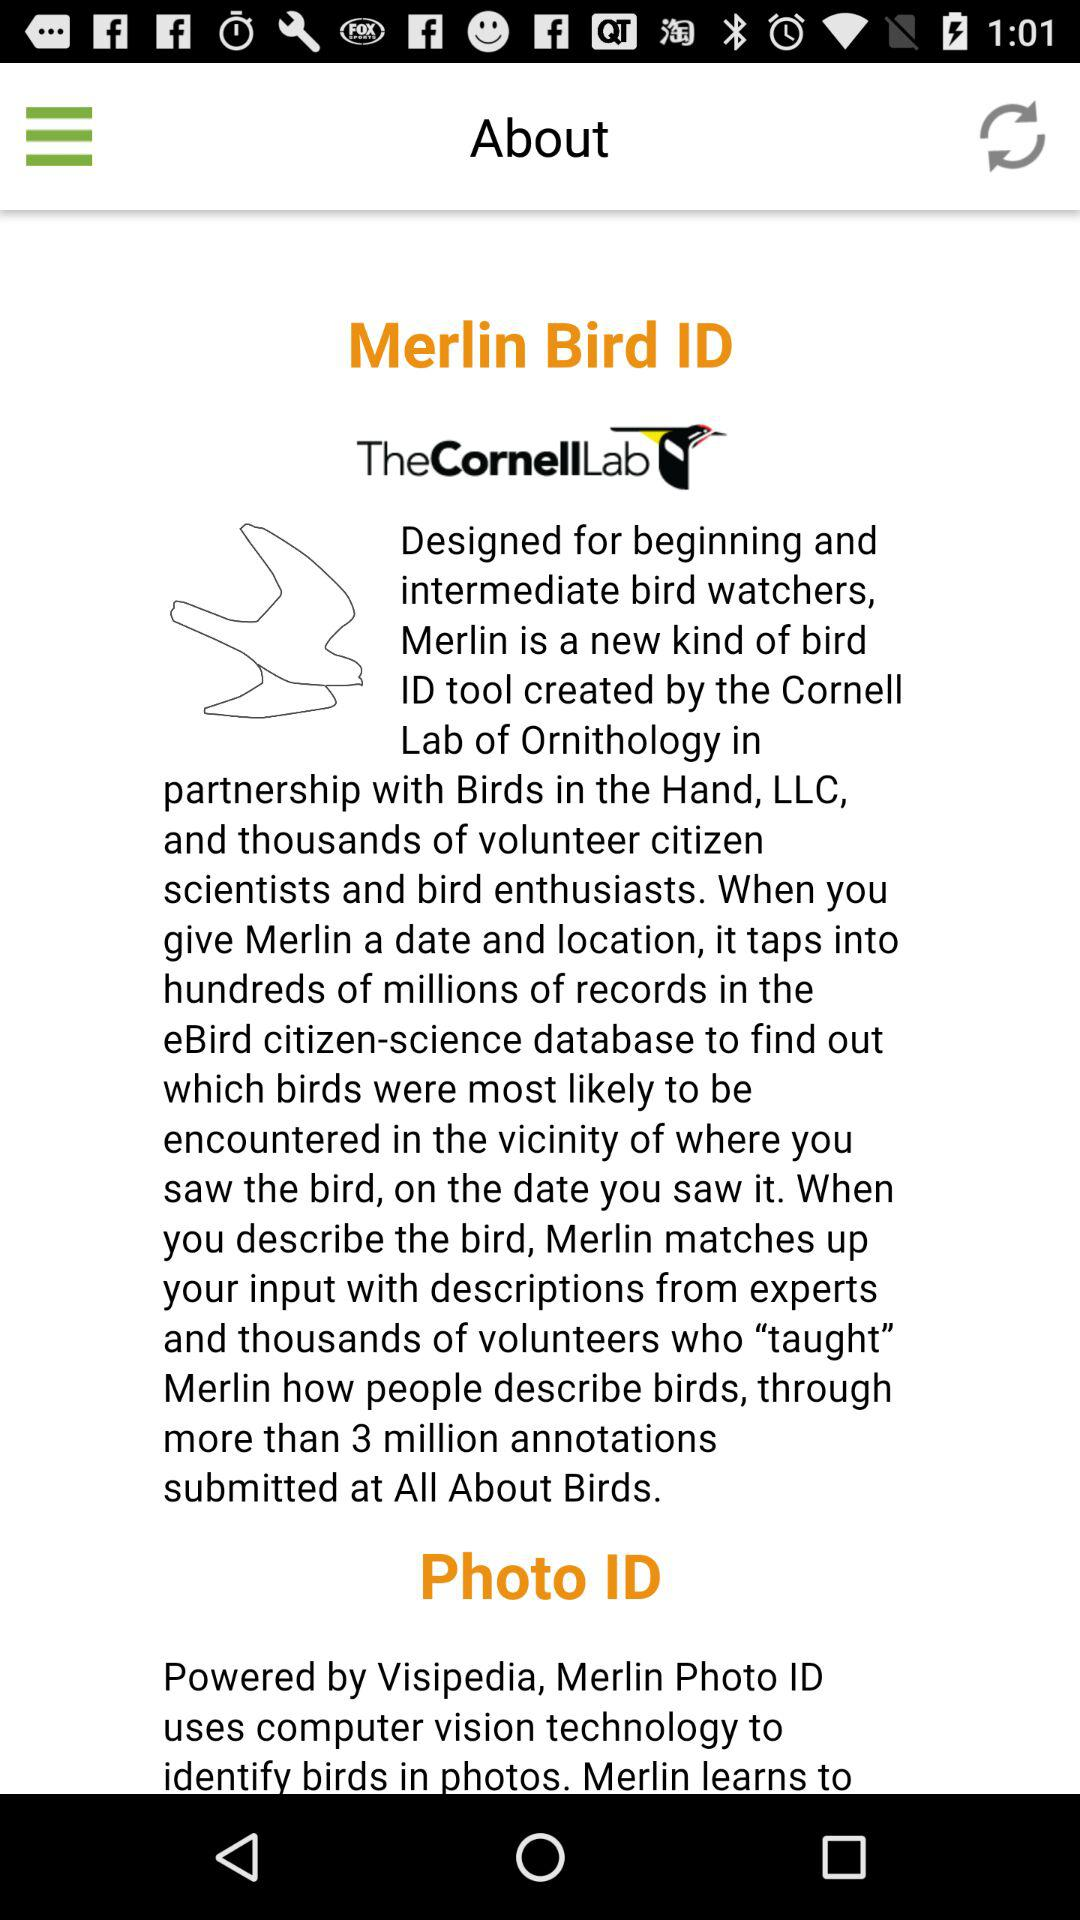What is Merlin Bird Id?
When the provided information is insufficient, respond with <no answer>. <no answer> 